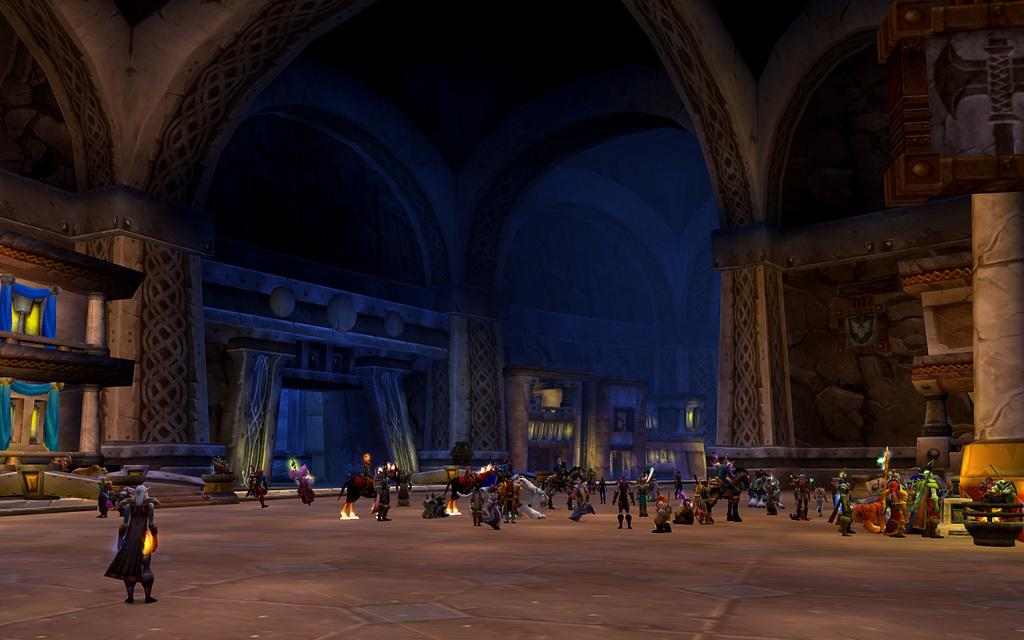What type of image is being described? The image is animated. What can be seen on the floor in the image? There is a group of toys on the floor. What architectural features are present in the image? There are pillars and a wall in the image. What type of window treatment is present in the image? There are curtains associated with the windows in the image. Can you see the father crossing the bridge on the island in the image? There is no father, bridge, or island present in the image. 